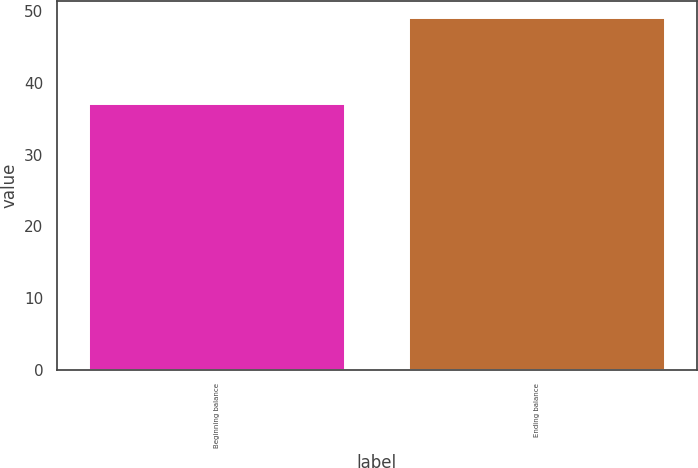Convert chart. <chart><loc_0><loc_0><loc_500><loc_500><bar_chart><fcel>Beginning balance<fcel>Ending balance<nl><fcel>37<fcel>49<nl></chart> 